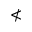<formula> <loc_0><loc_0><loc_500><loc_500>\nless</formula> 